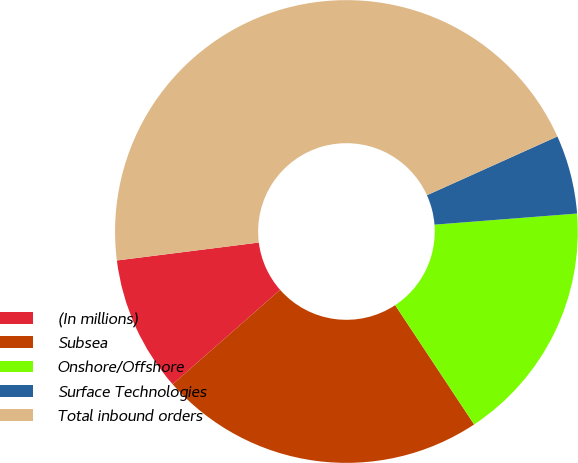Convert chart. <chart><loc_0><loc_0><loc_500><loc_500><pie_chart><fcel>(In millions)<fcel>Subsea<fcel>Onshore/Offshore<fcel>Surface Technologies<fcel>Total inbound orders<nl><fcel>9.48%<fcel>22.83%<fcel>16.93%<fcel>5.5%<fcel>45.26%<nl></chart> 